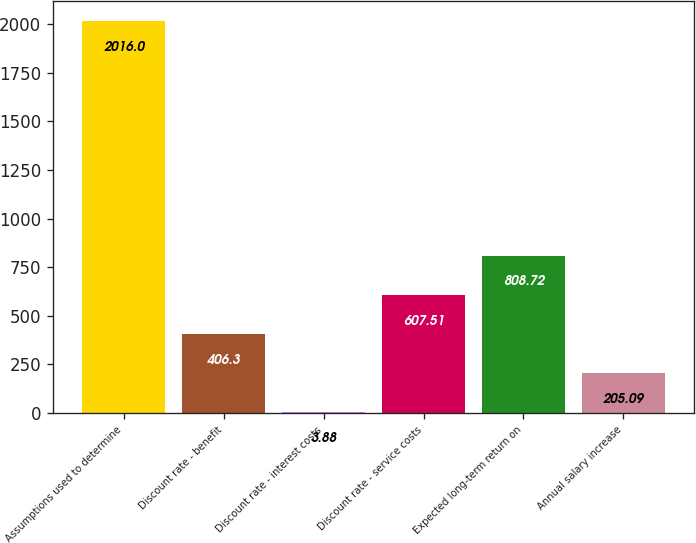Convert chart to OTSL. <chart><loc_0><loc_0><loc_500><loc_500><bar_chart><fcel>Assumptions used to determine<fcel>Discount rate - benefit<fcel>Discount rate - interest costs<fcel>Discount rate - service costs<fcel>Expected long-term return on<fcel>Annual salary increase<nl><fcel>2016<fcel>406.3<fcel>3.88<fcel>607.51<fcel>808.72<fcel>205.09<nl></chart> 